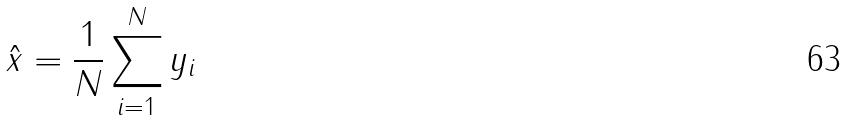Convert formula to latex. <formula><loc_0><loc_0><loc_500><loc_500>\hat { x } = \frac { 1 } { N } \sum _ { i = 1 } ^ { N } y _ { i }</formula> 